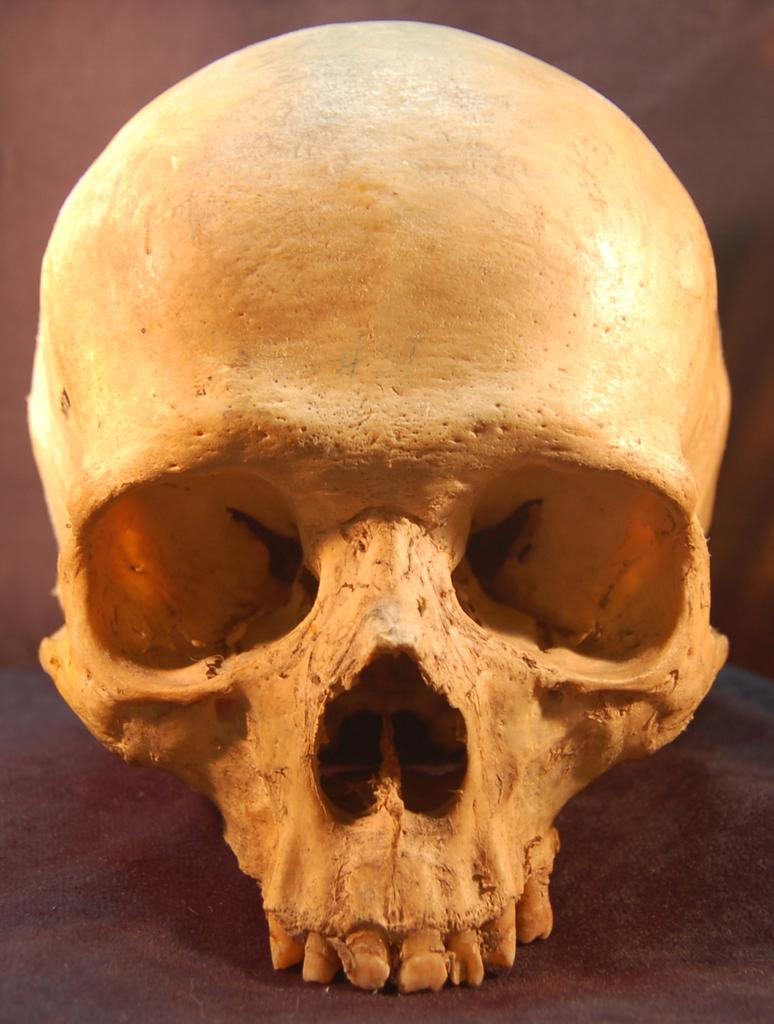What is the focus of the image? The image is zoomed in on a skull of a person. What is the skull placed on? The skull is placed on an object. What can be seen in the background of the image? There is a wall visible in the background of the image. What summer activities are the team members participating in near the skull? There is no reference to summer activities or a team in the image, so it's not possible to answer that question. 